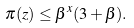<formula> <loc_0><loc_0><loc_500><loc_500>\pi ( z ) \leq \beta ^ { x } ( 3 + \beta ) .</formula> 